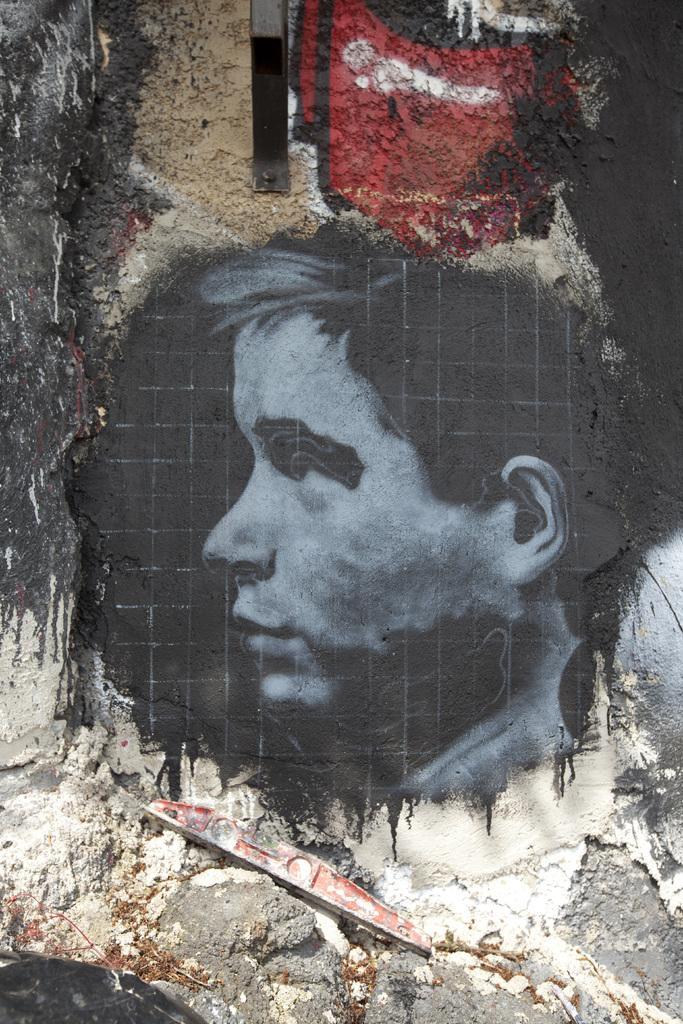What is depicted in the painting in the image? There is a painting of a person's head in the image. What type of material is present at the bottom of the image? There is sand at the bottom of the image. What can be found at the bottom of the image besides sand? There is an object at the bottom of the image. What is located at the top of the image? There is an object at the top of the image. What type of animal is depicted in the painting at the top of the image? There is no animal depicted in the painting; it is a painting of a person's head. What is the position of the governor in the image? There is no governor present in the image. 